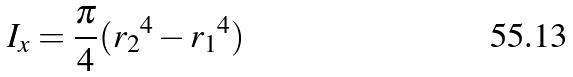Convert formula to latex. <formula><loc_0><loc_0><loc_500><loc_500>I _ { x } = \frac { \pi } { 4 } ( { r _ { 2 } } ^ { 4 } - { r _ { 1 } } ^ { 4 } )</formula> 